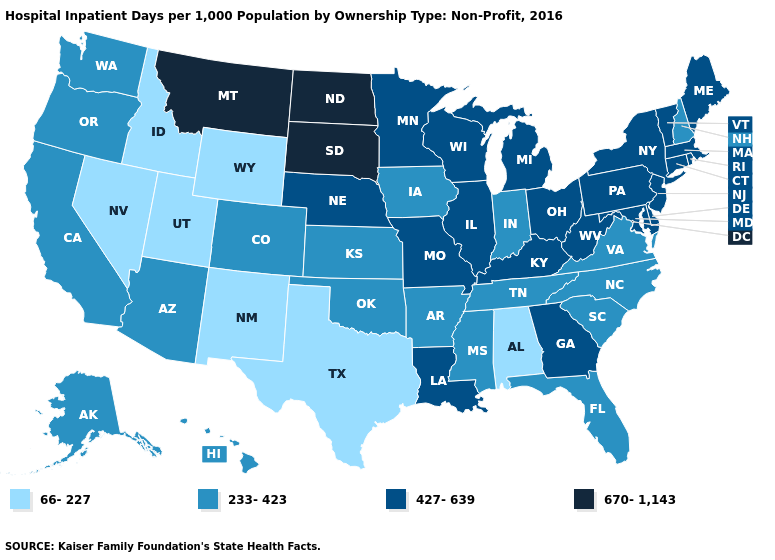Name the states that have a value in the range 427-639?
Write a very short answer. Connecticut, Delaware, Georgia, Illinois, Kentucky, Louisiana, Maine, Maryland, Massachusetts, Michigan, Minnesota, Missouri, Nebraska, New Jersey, New York, Ohio, Pennsylvania, Rhode Island, Vermont, West Virginia, Wisconsin. Among the states that border Massachusetts , which have the lowest value?
Quick response, please. New Hampshire. Name the states that have a value in the range 66-227?
Be succinct. Alabama, Idaho, Nevada, New Mexico, Texas, Utah, Wyoming. Does New Hampshire have the highest value in the Northeast?
Quick response, please. No. What is the value of New Jersey?
Concise answer only. 427-639. Which states have the highest value in the USA?
Concise answer only. Montana, North Dakota, South Dakota. Among the states that border Vermont , does New York have the highest value?
Be succinct. Yes. Among the states that border Arizona , which have the highest value?
Short answer required. California, Colorado. Does New Jersey have a higher value than New York?
Quick response, please. No. What is the value of Vermont?
Short answer required. 427-639. What is the highest value in the South ?
Be succinct. 427-639. Does Texas have the lowest value in the South?
Quick response, please. Yes. What is the value of Missouri?
Be succinct. 427-639. Name the states that have a value in the range 670-1,143?
Give a very brief answer. Montana, North Dakota, South Dakota. 